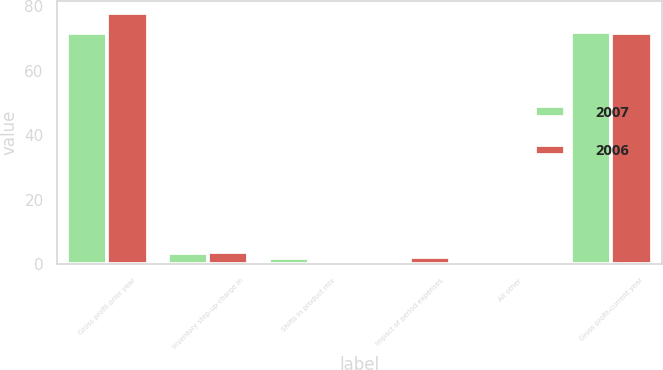Convert chart to OTSL. <chart><loc_0><loc_0><loc_500><loc_500><stacked_bar_chart><ecel><fcel>Gross profit-prior year<fcel>Inventory step-up charge in<fcel>Shifts in product mix<fcel>Impact of period expenses<fcel>All other<fcel>Gross profit-current year<nl><fcel>2007<fcel>71.8<fcel>3.4<fcel>1.8<fcel>0.8<fcel>0.2<fcel>72<nl><fcel>2006<fcel>77.9<fcel>3.8<fcel>0.8<fcel>2<fcel>0.5<fcel>71.8<nl></chart> 